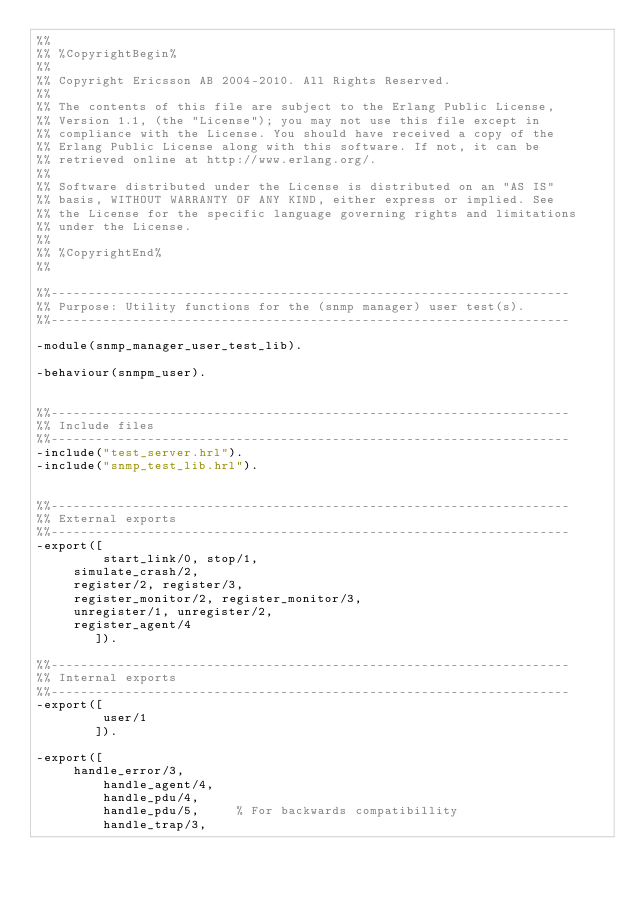<code> <loc_0><loc_0><loc_500><loc_500><_Erlang_>%% 
%% %CopyrightBegin%
%% 
%% Copyright Ericsson AB 2004-2010. All Rights Reserved.
%% 
%% The contents of this file are subject to the Erlang Public License,
%% Version 1.1, (the "License"); you may not use this file except in
%% compliance with the License. You should have received a copy of the
%% Erlang Public License along with this software. If not, it can be
%% retrieved online at http://www.erlang.org/.
%% 
%% Software distributed under the License is distributed on an "AS IS"
%% basis, WITHOUT WARRANTY OF ANY KIND, either express or implied. See
%% the License for the specific language governing rights and limitations
%% under the License.
%% 
%% %CopyrightEnd%
%% 

%%----------------------------------------------------------------------
%% Purpose: Utility functions for the (snmp manager) user test(s).
%%----------------------------------------------------------------------

-module(snmp_manager_user_test_lib).

-behaviour(snmpm_user).


%%----------------------------------------------------------------------
%% Include files
%%----------------------------------------------------------------------
-include("test_server.hrl").
-include("snmp_test_lib.hrl").


%%----------------------------------------------------------------------
%% External exports
%%----------------------------------------------------------------------
-export([
         start_link/0, stop/1,
	 simulate_crash/2,
	 register/2, register/3, 
	 register_monitor/2, register_monitor/3, 
	 unregister/1, unregister/2,
	 register_agent/4
        ]).

%%----------------------------------------------------------------------
%% Internal exports
%%----------------------------------------------------------------------
-export([
         user/1
        ]).

-export([
	 handle_error/3,
         handle_agent/4,
         handle_pdu/4,
         handle_pdu/5,     % For backwards compatibillity 
         handle_trap/3,</code> 